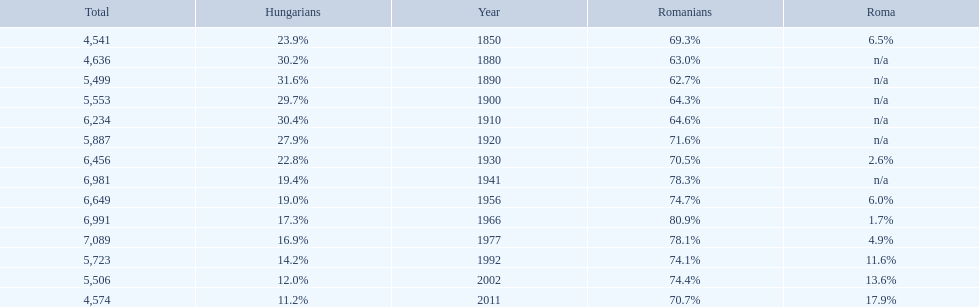Could you parse the entire table? {'header': ['Total', 'Hungarians', 'Year', 'Romanians', 'Roma'], 'rows': [['4,541', '23.9%', '1850', '69.3%', '6.5%'], ['4,636', '30.2%', '1880', '63.0%', 'n/a'], ['5,499', '31.6%', '1890', '62.7%', 'n/a'], ['5,553', '29.7%', '1900', '64.3%', 'n/a'], ['6,234', '30.4%', '1910', '64.6%', 'n/a'], ['5,887', '27.9%', '1920', '71.6%', 'n/a'], ['6,456', '22.8%', '1930', '70.5%', '2.6%'], ['6,981', '19.4%', '1941', '78.3%', 'n/a'], ['6,649', '19.0%', '1956', '74.7%', '6.0%'], ['6,991', '17.3%', '1966', '80.9%', '1.7%'], ['7,089', '16.9%', '1977', '78.1%', '4.9%'], ['5,723', '14.2%', '1992', '74.1%', '11.6%'], ['5,506', '12.0%', '2002', '74.4%', '13.6%'], ['4,574', '11.2%', '2011', '70.7%', '17.9%']]} Which year is previous to the year that had 74.1% in romanian population? 1977. 